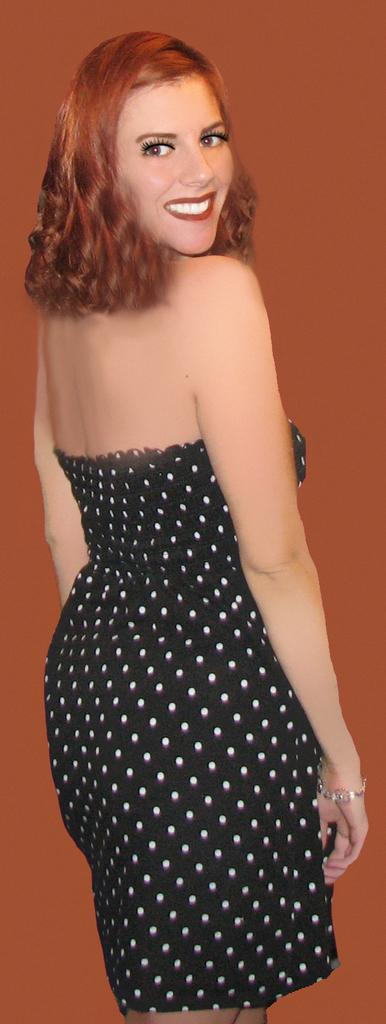Who is present in the image? There is a lady in the image. What can be observed about the background of the image? The background of the image is orange in color. What type of oil is being used by the snail in the image? There is no snail present in the image, and therefore no oil usage can be observed. 